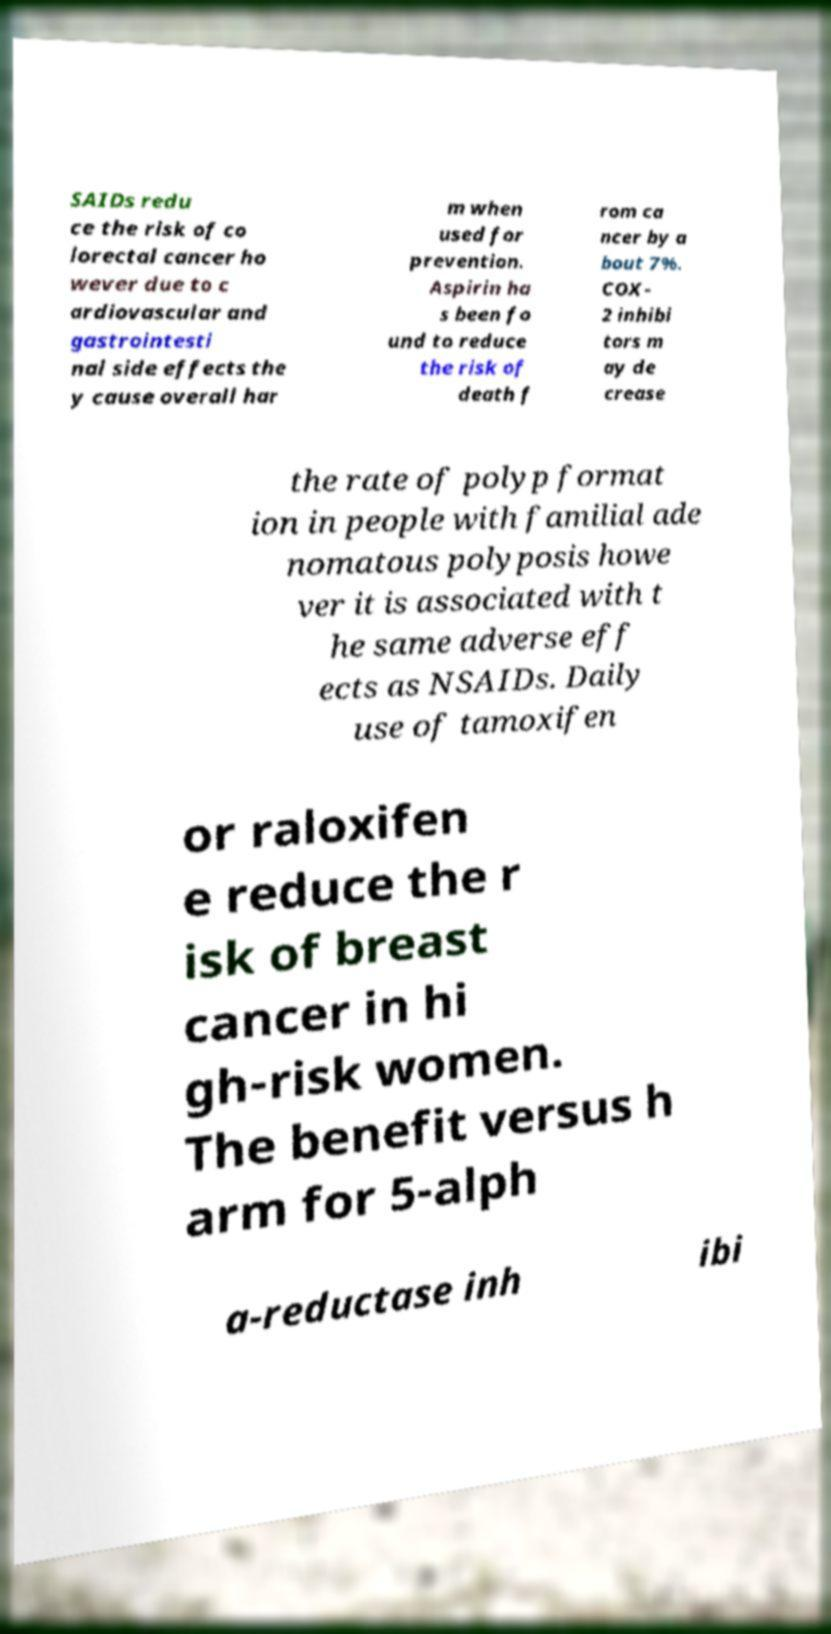What messages or text are displayed in this image? I need them in a readable, typed format. SAIDs redu ce the risk of co lorectal cancer ho wever due to c ardiovascular and gastrointesti nal side effects the y cause overall har m when used for prevention. Aspirin ha s been fo und to reduce the risk of death f rom ca ncer by a bout 7%. COX- 2 inhibi tors m ay de crease the rate of polyp format ion in people with familial ade nomatous polyposis howe ver it is associated with t he same adverse eff ects as NSAIDs. Daily use of tamoxifen or raloxifen e reduce the r isk of breast cancer in hi gh-risk women. The benefit versus h arm for 5-alph a-reductase inh ibi 